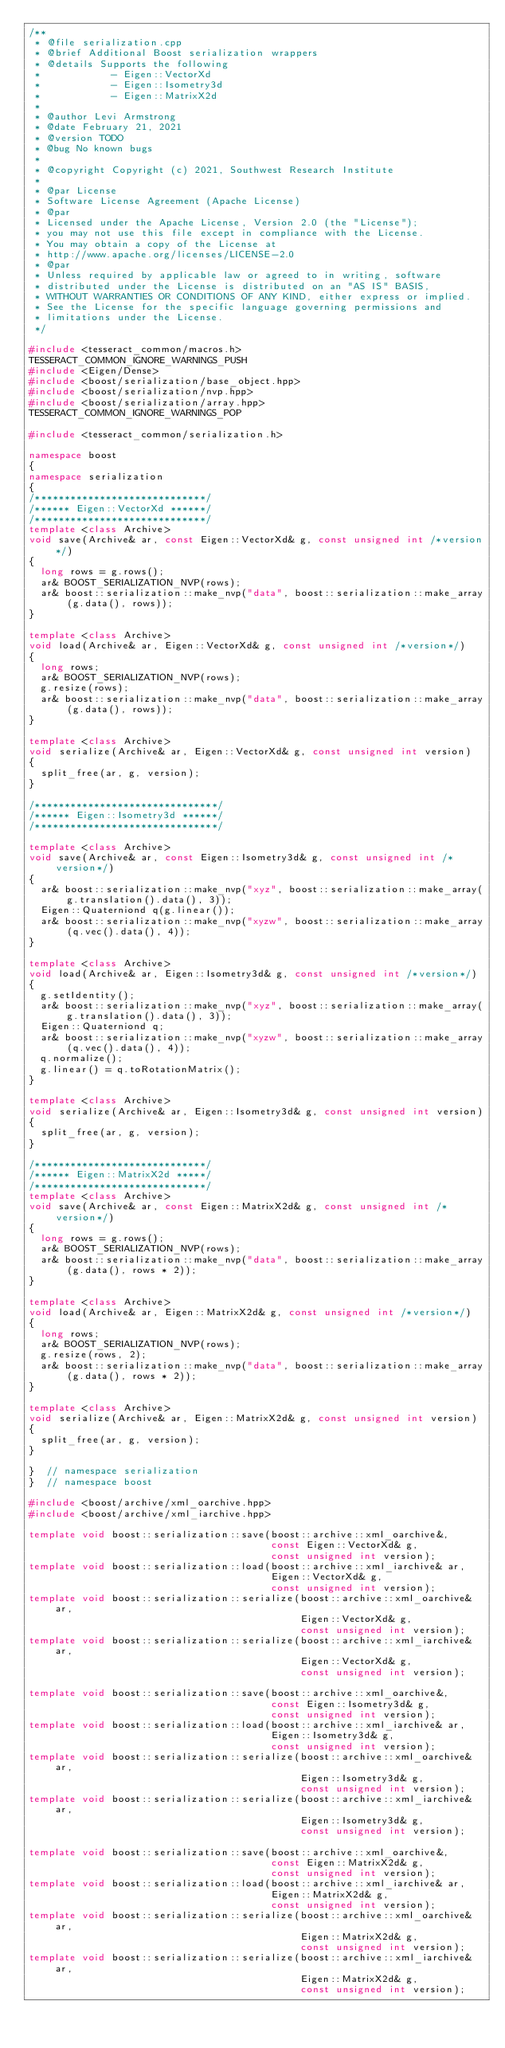Convert code to text. <code><loc_0><loc_0><loc_500><loc_500><_C++_>/**
 * @file serialization.cpp
 * @brief Additional Boost serialization wrappers
 * @details Supports the following
 *            - Eigen::VectorXd
 *            - Eigen::Isometry3d
 *            - Eigen::MatrixX2d
 *
 * @author Levi Armstrong
 * @date February 21, 2021
 * @version TODO
 * @bug No known bugs
 *
 * @copyright Copyright (c) 2021, Southwest Research Institute
 *
 * @par License
 * Software License Agreement (Apache License)
 * @par
 * Licensed under the Apache License, Version 2.0 (the "License");
 * you may not use this file except in compliance with the License.
 * You may obtain a copy of the License at
 * http://www.apache.org/licenses/LICENSE-2.0
 * @par
 * Unless required by applicable law or agreed to in writing, software
 * distributed under the License is distributed on an "AS IS" BASIS,
 * WITHOUT WARRANTIES OR CONDITIONS OF ANY KIND, either express or implied.
 * See the License for the specific language governing permissions and
 * limitations under the License.
 */

#include <tesseract_common/macros.h>
TESSERACT_COMMON_IGNORE_WARNINGS_PUSH
#include <Eigen/Dense>
#include <boost/serialization/base_object.hpp>
#include <boost/serialization/nvp.hpp>
#include <boost/serialization/array.hpp>
TESSERACT_COMMON_IGNORE_WARNINGS_POP

#include <tesseract_common/serialization.h>

namespace boost
{
namespace serialization
{
/*****************************/
/****** Eigen::VectorXd ******/
/*****************************/
template <class Archive>
void save(Archive& ar, const Eigen::VectorXd& g, const unsigned int /*version*/)
{
  long rows = g.rows();
  ar& BOOST_SERIALIZATION_NVP(rows);
  ar& boost::serialization::make_nvp("data", boost::serialization::make_array(g.data(), rows));
}

template <class Archive>
void load(Archive& ar, Eigen::VectorXd& g, const unsigned int /*version*/)
{
  long rows;
  ar& BOOST_SERIALIZATION_NVP(rows);
  g.resize(rows);
  ar& boost::serialization::make_nvp("data", boost::serialization::make_array(g.data(), rows));
}

template <class Archive>
void serialize(Archive& ar, Eigen::VectorXd& g, const unsigned int version)
{
  split_free(ar, g, version);
}

/*******************************/
/****** Eigen::Isometry3d ******/
/*******************************/

template <class Archive>
void save(Archive& ar, const Eigen::Isometry3d& g, const unsigned int /*version*/)
{
  ar& boost::serialization::make_nvp("xyz", boost::serialization::make_array(g.translation().data(), 3));
  Eigen::Quaterniond q(g.linear());
  ar& boost::serialization::make_nvp("xyzw", boost::serialization::make_array(q.vec().data(), 4));
}

template <class Archive>
void load(Archive& ar, Eigen::Isometry3d& g, const unsigned int /*version*/)
{
  g.setIdentity();
  ar& boost::serialization::make_nvp("xyz", boost::serialization::make_array(g.translation().data(), 3));
  Eigen::Quaterniond q;
  ar& boost::serialization::make_nvp("xyzw", boost::serialization::make_array(q.vec().data(), 4));
  q.normalize();
  g.linear() = q.toRotationMatrix();
}

template <class Archive>
void serialize(Archive& ar, Eigen::Isometry3d& g, const unsigned int version)
{
  split_free(ar, g, version);
}

/*****************************/
/****** Eigen::MatrixX2d *****/
/*****************************/
template <class Archive>
void save(Archive& ar, const Eigen::MatrixX2d& g, const unsigned int /*version*/)
{
  long rows = g.rows();
  ar& BOOST_SERIALIZATION_NVP(rows);
  ar& boost::serialization::make_nvp("data", boost::serialization::make_array(g.data(), rows * 2));
}

template <class Archive>
void load(Archive& ar, Eigen::MatrixX2d& g, const unsigned int /*version*/)
{
  long rows;
  ar& BOOST_SERIALIZATION_NVP(rows);
  g.resize(rows, 2);
  ar& boost::serialization::make_nvp("data", boost::serialization::make_array(g.data(), rows * 2));
}

template <class Archive>
void serialize(Archive& ar, Eigen::MatrixX2d& g, const unsigned int version)
{
  split_free(ar, g, version);
}

}  // namespace serialization
}  // namespace boost

#include <boost/archive/xml_oarchive.hpp>
#include <boost/archive/xml_iarchive.hpp>

template void boost::serialization::save(boost::archive::xml_oarchive&,
                                         const Eigen::VectorXd& g,
                                         const unsigned int version);
template void boost::serialization::load(boost::archive::xml_iarchive& ar,
                                         Eigen::VectorXd& g,
                                         const unsigned int version);
template void boost::serialization::serialize(boost::archive::xml_oarchive& ar,
                                              Eigen::VectorXd& g,
                                              const unsigned int version);
template void boost::serialization::serialize(boost::archive::xml_iarchive& ar,
                                              Eigen::VectorXd& g,
                                              const unsigned int version);

template void boost::serialization::save(boost::archive::xml_oarchive&,
                                         const Eigen::Isometry3d& g,
                                         const unsigned int version);
template void boost::serialization::load(boost::archive::xml_iarchive& ar,
                                         Eigen::Isometry3d& g,
                                         const unsigned int version);
template void boost::serialization::serialize(boost::archive::xml_oarchive& ar,
                                              Eigen::Isometry3d& g,
                                              const unsigned int version);
template void boost::serialization::serialize(boost::archive::xml_iarchive& ar,
                                              Eigen::Isometry3d& g,
                                              const unsigned int version);

template void boost::serialization::save(boost::archive::xml_oarchive&,
                                         const Eigen::MatrixX2d& g,
                                         const unsigned int version);
template void boost::serialization::load(boost::archive::xml_iarchive& ar,
                                         Eigen::MatrixX2d& g,
                                         const unsigned int version);
template void boost::serialization::serialize(boost::archive::xml_oarchive& ar,
                                              Eigen::MatrixX2d& g,
                                              const unsigned int version);
template void boost::serialization::serialize(boost::archive::xml_iarchive& ar,
                                              Eigen::MatrixX2d& g,
                                              const unsigned int version);
</code> 